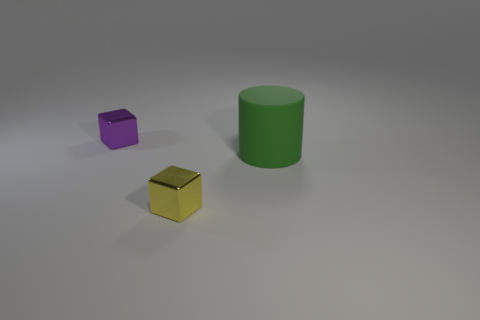Are there any other things that are the same size as the green cylinder?
Keep it short and to the point. No. Are there any other things that are the same material as the large cylinder?
Keep it short and to the point. No. Are there the same number of green objects to the left of the matte cylinder and big gray metallic objects?
Your answer should be very brief. Yes. What number of objects are metallic objects in front of the small purple metallic object or small green matte spheres?
Make the answer very short. 1. How big is the purple object behind the matte object?
Your response must be concise. Small. There is a shiny thing that is right of the cube that is behind the yellow shiny thing; what is its shape?
Provide a short and direct response. Cube. What color is the other tiny shiny object that is the same shape as the yellow shiny object?
Keep it short and to the point. Purple. Does the metal thing behind the yellow block have the same size as the yellow metallic block?
Offer a terse response. Yes. What number of purple cubes are made of the same material as the tiny yellow object?
Your answer should be compact. 1. What is the green object that is right of the small purple metallic thing to the left of the small block in front of the green matte cylinder made of?
Keep it short and to the point. Rubber. 